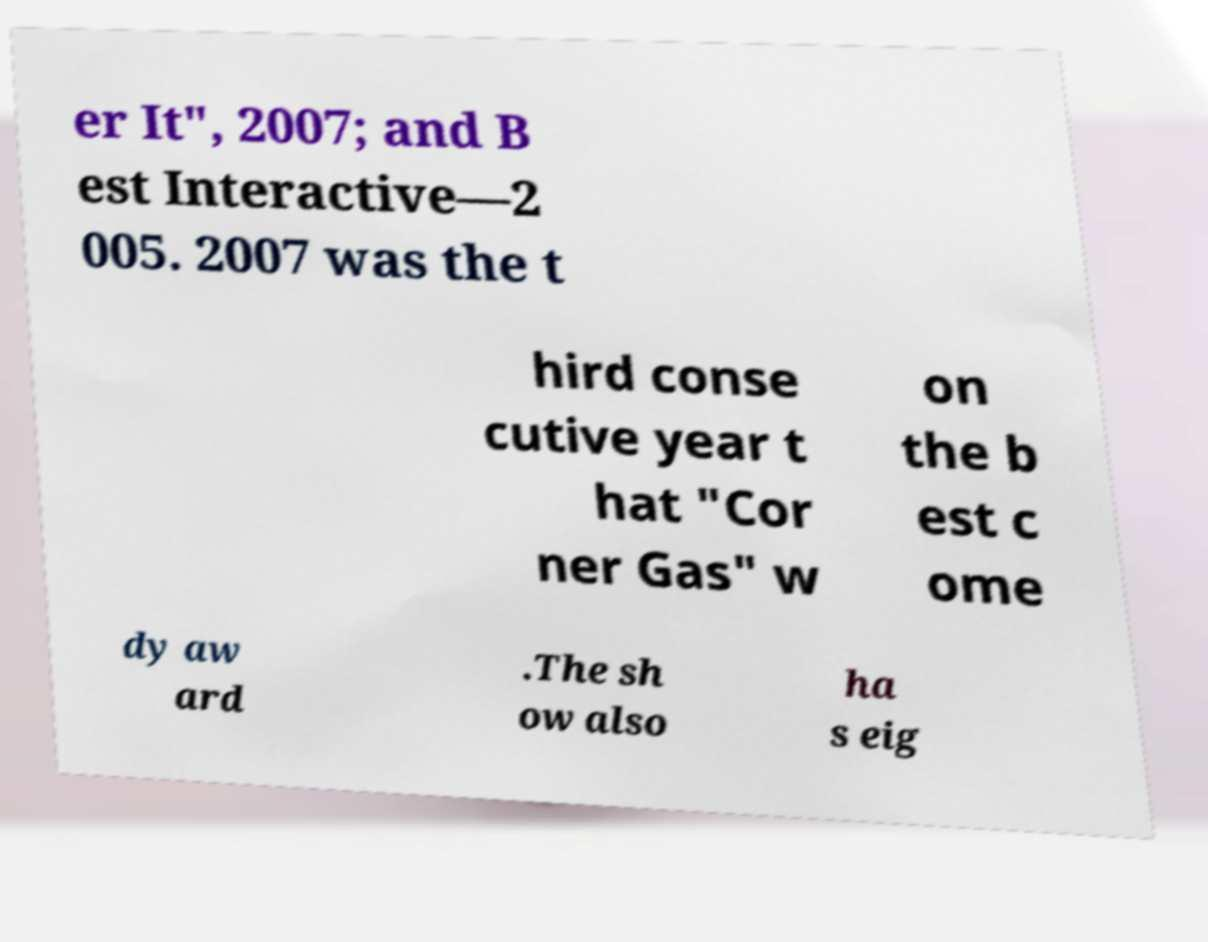Can you accurately transcribe the text from the provided image for me? er It", 2007; and B est Interactive—2 005. 2007 was the t hird conse cutive year t hat "Cor ner Gas" w on the b est c ome dy aw ard .The sh ow also ha s eig 